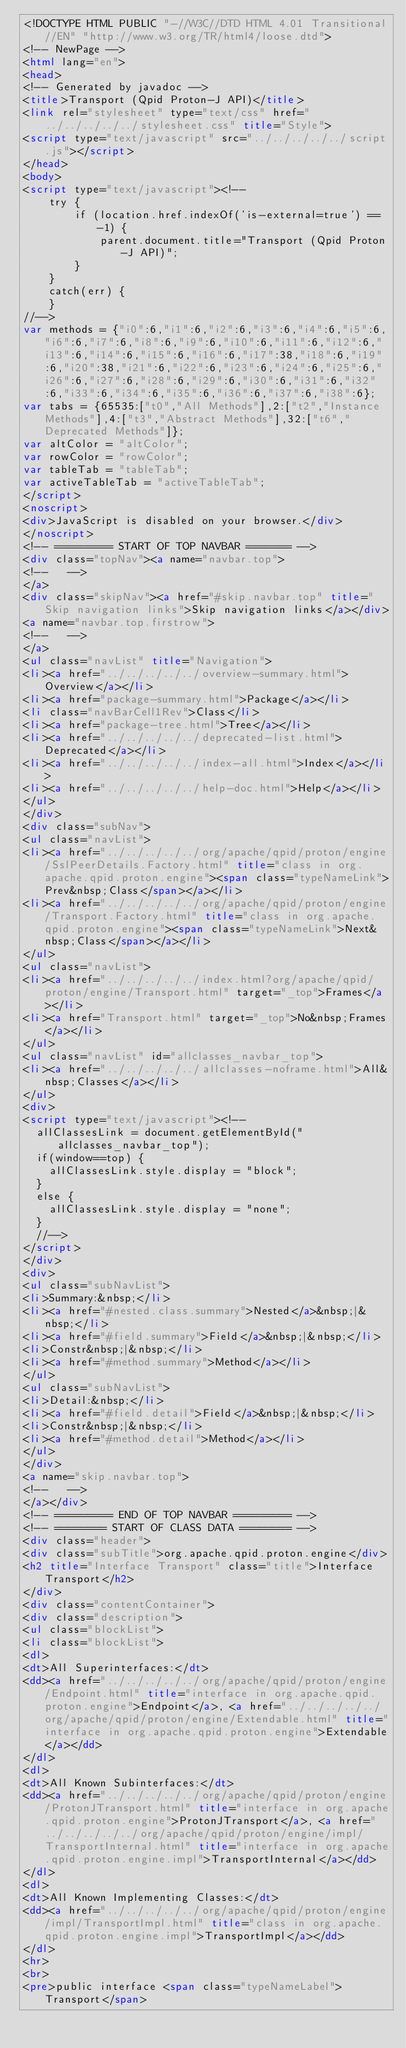Convert code to text. <code><loc_0><loc_0><loc_500><loc_500><_HTML_><!DOCTYPE HTML PUBLIC "-//W3C//DTD HTML 4.01 Transitional//EN" "http://www.w3.org/TR/html4/loose.dtd">
<!-- NewPage -->
<html lang="en">
<head>
<!-- Generated by javadoc -->
<title>Transport (Qpid Proton-J API)</title>
<link rel="stylesheet" type="text/css" href="../../../../../stylesheet.css" title="Style">
<script type="text/javascript" src="../../../../../script.js"></script>
</head>
<body>
<script type="text/javascript"><!--
    try {
        if (location.href.indexOf('is-external=true') == -1) {
            parent.document.title="Transport (Qpid Proton-J API)";
        }
    }
    catch(err) {
    }
//-->
var methods = {"i0":6,"i1":6,"i2":6,"i3":6,"i4":6,"i5":6,"i6":6,"i7":6,"i8":6,"i9":6,"i10":6,"i11":6,"i12":6,"i13":6,"i14":6,"i15":6,"i16":6,"i17":38,"i18":6,"i19":6,"i20":38,"i21":6,"i22":6,"i23":6,"i24":6,"i25":6,"i26":6,"i27":6,"i28":6,"i29":6,"i30":6,"i31":6,"i32":6,"i33":6,"i34":6,"i35":6,"i36":6,"i37":6,"i38":6};
var tabs = {65535:["t0","All Methods"],2:["t2","Instance Methods"],4:["t3","Abstract Methods"],32:["t6","Deprecated Methods"]};
var altColor = "altColor";
var rowColor = "rowColor";
var tableTab = "tableTab";
var activeTableTab = "activeTableTab";
</script>
<noscript>
<div>JavaScript is disabled on your browser.</div>
</noscript>
<!-- ========= START OF TOP NAVBAR ======= -->
<div class="topNav"><a name="navbar.top">
<!--   -->
</a>
<div class="skipNav"><a href="#skip.navbar.top" title="Skip navigation links">Skip navigation links</a></div>
<a name="navbar.top.firstrow">
<!--   -->
</a>
<ul class="navList" title="Navigation">
<li><a href="../../../../../overview-summary.html">Overview</a></li>
<li><a href="package-summary.html">Package</a></li>
<li class="navBarCell1Rev">Class</li>
<li><a href="package-tree.html">Tree</a></li>
<li><a href="../../../../../deprecated-list.html">Deprecated</a></li>
<li><a href="../../../../../index-all.html">Index</a></li>
<li><a href="../../../../../help-doc.html">Help</a></li>
</ul>
</div>
<div class="subNav">
<ul class="navList">
<li><a href="../../../../../org/apache/qpid/proton/engine/SslPeerDetails.Factory.html" title="class in org.apache.qpid.proton.engine"><span class="typeNameLink">Prev&nbsp;Class</span></a></li>
<li><a href="../../../../../org/apache/qpid/proton/engine/Transport.Factory.html" title="class in org.apache.qpid.proton.engine"><span class="typeNameLink">Next&nbsp;Class</span></a></li>
</ul>
<ul class="navList">
<li><a href="../../../../../index.html?org/apache/qpid/proton/engine/Transport.html" target="_top">Frames</a></li>
<li><a href="Transport.html" target="_top">No&nbsp;Frames</a></li>
</ul>
<ul class="navList" id="allclasses_navbar_top">
<li><a href="../../../../../allclasses-noframe.html">All&nbsp;Classes</a></li>
</ul>
<div>
<script type="text/javascript"><!--
  allClassesLink = document.getElementById("allclasses_navbar_top");
  if(window==top) {
    allClassesLink.style.display = "block";
  }
  else {
    allClassesLink.style.display = "none";
  }
  //-->
</script>
</div>
<div>
<ul class="subNavList">
<li>Summary:&nbsp;</li>
<li><a href="#nested.class.summary">Nested</a>&nbsp;|&nbsp;</li>
<li><a href="#field.summary">Field</a>&nbsp;|&nbsp;</li>
<li>Constr&nbsp;|&nbsp;</li>
<li><a href="#method.summary">Method</a></li>
</ul>
<ul class="subNavList">
<li>Detail:&nbsp;</li>
<li><a href="#field.detail">Field</a>&nbsp;|&nbsp;</li>
<li>Constr&nbsp;|&nbsp;</li>
<li><a href="#method.detail">Method</a></li>
</ul>
</div>
<a name="skip.navbar.top">
<!--   -->
</a></div>
<!-- ========= END OF TOP NAVBAR ========= -->
<!-- ======== START OF CLASS DATA ======== -->
<div class="header">
<div class="subTitle">org.apache.qpid.proton.engine</div>
<h2 title="Interface Transport" class="title">Interface Transport</h2>
</div>
<div class="contentContainer">
<div class="description">
<ul class="blockList">
<li class="blockList">
<dl>
<dt>All Superinterfaces:</dt>
<dd><a href="../../../../../org/apache/qpid/proton/engine/Endpoint.html" title="interface in org.apache.qpid.proton.engine">Endpoint</a>, <a href="../../../../../org/apache/qpid/proton/engine/Extendable.html" title="interface in org.apache.qpid.proton.engine">Extendable</a></dd>
</dl>
<dl>
<dt>All Known Subinterfaces:</dt>
<dd><a href="../../../../../org/apache/qpid/proton/engine/ProtonJTransport.html" title="interface in org.apache.qpid.proton.engine">ProtonJTransport</a>, <a href="../../../../../org/apache/qpid/proton/engine/impl/TransportInternal.html" title="interface in org.apache.qpid.proton.engine.impl">TransportInternal</a></dd>
</dl>
<dl>
<dt>All Known Implementing Classes:</dt>
<dd><a href="../../../../../org/apache/qpid/proton/engine/impl/TransportImpl.html" title="class in org.apache.qpid.proton.engine.impl">TransportImpl</a></dd>
</dl>
<hr>
<br>
<pre>public interface <span class="typeNameLabel">Transport</span></code> 